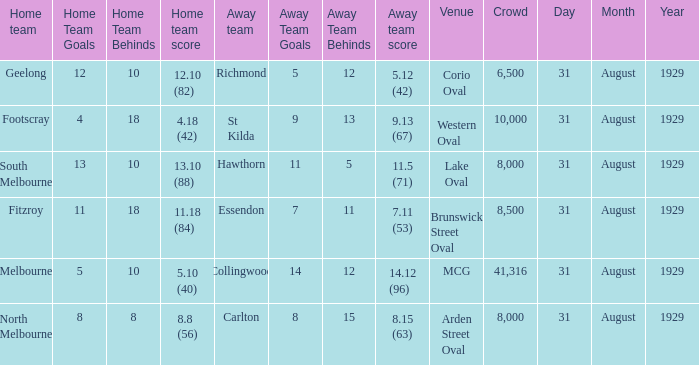What was the away team when the game was at corio oval? Richmond. 